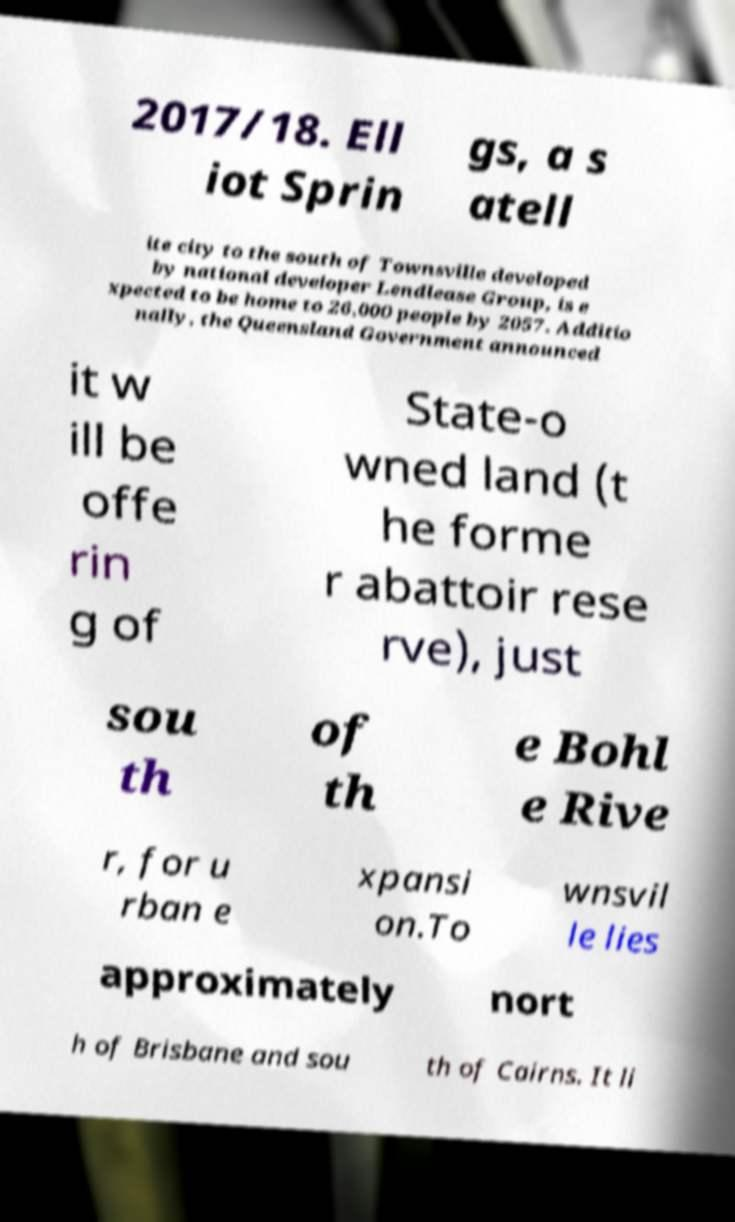Please read and relay the text visible in this image. What does it say? 2017/18. Ell iot Sprin gs, a s atell ite city to the south of Townsville developed by national developer Lendlease Group, is e xpected to be home to 26,000 people by 2057. Additio nally, the Queensland Government announced it w ill be offe rin g of State-o wned land (t he forme r abattoir rese rve), just sou th of th e Bohl e Rive r, for u rban e xpansi on.To wnsvil le lies approximately nort h of Brisbane and sou th of Cairns. It li 